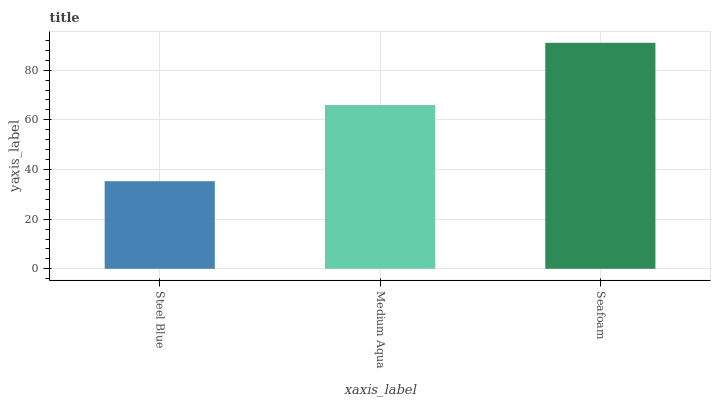Is Steel Blue the minimum?
Answer yes or no. Yes. Is Seafoam the maximum?
Answer yes or no. Yes. Is Medium Aqua the minimum?
Answer yes or no. No. Is Medium Aqua the maximum?
Answer yes or no. No. Is Medium Aqua greater than Steel Blue?
Answer yes or no. Yes. Is Steel Blue less than Medium Aqua?
Answer yes or no. Yes. Is Steel Blue greater than Medium Aqua?
Answer yes or no. No. Is Medium Aqua less than Steel Blue?
Answer yes or no. No. Is Medium Aqua the high median?
Answer yes or no. Yes. Is Medium Aqua the low median?
Answer yes or no. Yes. Is Seafoam the high median?
Answer yes or no. No. Is Seafoam the low median?
Answer yes or no. No. 